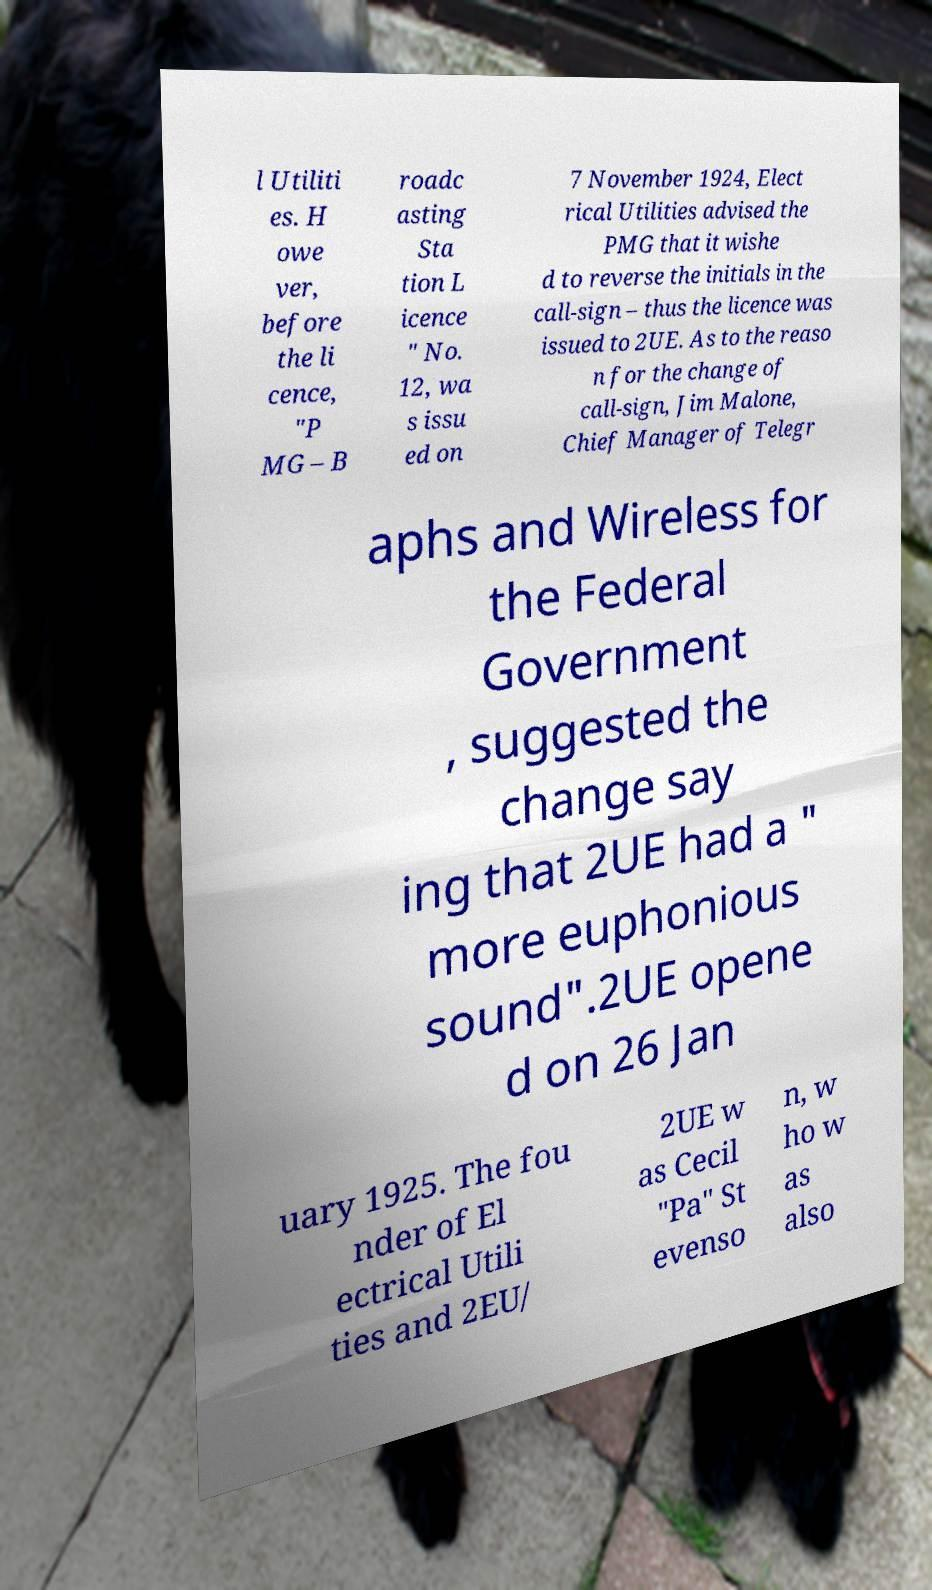Can you read and provide the text displayed in the image?This photo seems to have some interesting text. Can you extract and type it out for me? l Utiliti es. H owe ver, before the li cence, "P MG – B roadc asting Sta tion L icence " No. 12, wa s issu ed on 7 November 1924, Elect rical Utilities advised the PMG that it wishe d to reverse the initials in the call-sign – thus the licence was issued to 2UE. As to the reaso n for the change of call-sign, Jim Malone, Chief Manager of Telegr aphs and Wireless for the Federal Government , suggested the change say ing that 2UE had a " more euphonious sound".2UE opene d on 26 Jan uary 1925. The fou nder of El ectrical Utili ties and 2EU/ 2UE w as Cecil "Pa" St evenso n, w ho w as also 